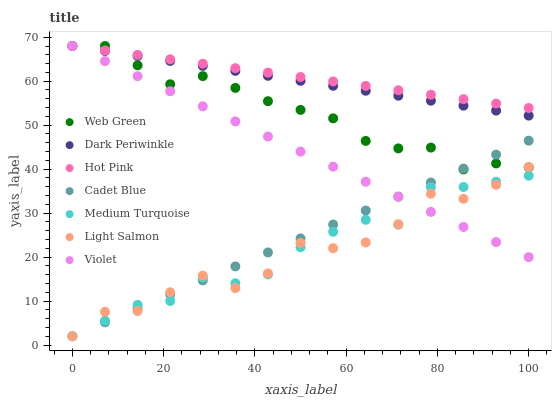Does Light Salmon have the minimum area under the curve?
Answer yes or no. Yes. Does Hot Pink have the maximum area under the curve?
Answer yes or no. Yes. Does Cadet Blue have the minimum area under the curve?
Answer yes or no. No. Does Cadet Blue have the maximum area under the curve?
Answer yes or no. No. Is Cadet Blue the smoothest?
Answer yes or no. Yes. Is Light Salmon the roughest?
Answer yes or no. Yes. Is Hot Pink the smoothest?
Answer yes or no. No. Is Hot Pink the roughest?
Answer yes or no. No. Does Light Salmon have the lowest value?
Answer yes or no. Yes. Does Hot Pink have the lowest value?
Answer yes or no. No. Does Dark Periwinkle have the highest value?
Answer yes or no. Yes. Does Cadet Blue have the highest value?
Answer yes or no. No. Is Cadet Blue less than Dark Periwinkle?
Answer yes or no. Yes. Is Dark Periwinkle greater than Light Salmon?
Answer yes or no. Yes. Does Web Green intersect Dark Periwinkle?
Answer yes or no. Yes. Is Web Green less than Dark Periwinkle?
Answer yes or no. No. Is Web Green greater than Dark Periwinkle?
Answer yes or no. No. Does Cadet Blue intersect Dark Periwinkle?
Answer yes or no. No. 